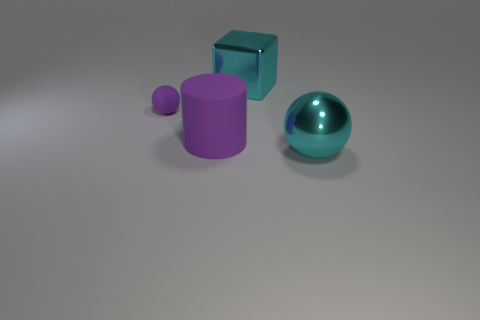Add 3 cyan rubber blocks. How many objects exist? 7 Subtract all cylinders. How many objects are left? 3 Subtract 1 purple cylinders. How many objects are left? 3 Subtract all shiny objects. Subtract all purple rubber objects. How many objects are left? 0 Add 4 cyan shiny blocks. How many cyan shiny blocks are left? 5 Add 1 large metallic cubes. How many large metallic cubes exist? 2 